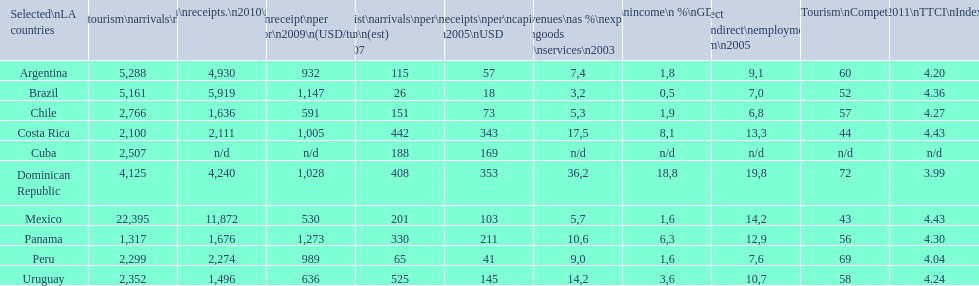What country had the most receipts per capita in 2005? Dominican Republic. 